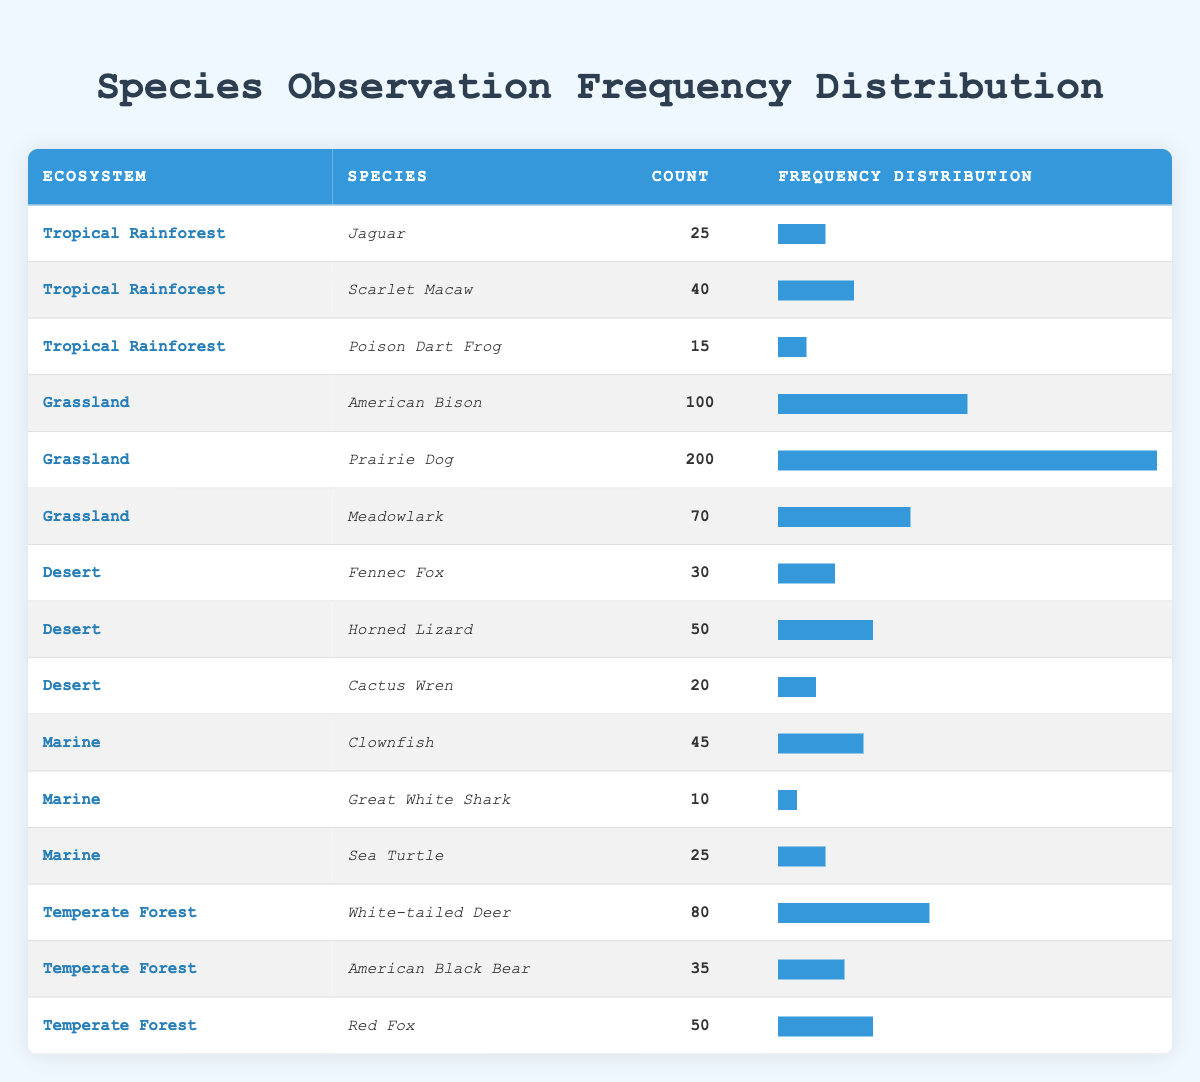What is the highest species observation count in the Grassland ecosystem? By reviewing the Grassland entries, I can see the counts for the species: American Bison (100), Prairie Dog (200), and Meadowlark (70). The highest count is 200 for the Prairie Dog.
Answer: 200 Which species has the lowest observation count in the Tropical Rainforest? In the Tropical Rainforest section, the counts are Jaguar (25), Scarlet Macaw (40), and Poison Dart Frog (15). The Poison Dart Frog has the lowest count at 15.
Answer: 15 Is it true that the Marine ecosystem has more species observed than the Desert ecosystem? The Marine ecosystem lists three species (Clownfish, Great White Shark, Sea Turtle), while the Desert ecosystem lists three as well (Fennec Fox, Horned Lizard, Cactus Wren); therefore, both have the same number of species observed, making the statement false.
Answer: No What is the total observation count for all species in the Temperate Forest ecosystem? The species in the Temperate Forest are White-tailed Deer (80), American Black Bear (35), and Red Fox (50). Adding these counts: 80 + 35 + 50 = 165 gives a total observation count of 165.
Answer: 165 What percentage of the total observation counts does the Prairie Dog represent? The total counts across all species are calculated as follows: 25 (Jaguar) + 40 (Scarlet Macaw) + 15 (Poison Dart Frog) + 100 (American Bison) + 200 (Prairie Dog) + 70 (Meadowlark) + 30 (Fennec Fox) + 50 (Horned Lizard) + 20 (Cactus Wren) + 45 (Clownfish) + 10 (Great White Shark) + 25 (Sea Turtle) + 80 (White-tailed Deer) + 35 (American Black Bear) + 50 (Red Fox) = 680. The count for Prairie Dog is 200. To find the percentage: (200/680) * 100 = 29.41%.
Answer: 29.41% How many ecosystems have a species with an observation count of 50 or more? Looking through each ecosystem's observations, the following counts are 100 (Grassland, American Bison), 200 (Grassland, Prairie Dog), 70 (Grassland, Meadowlark), 50 (Desert, Horned Lizard), 45 (Marine, Clownfish), 80 (Temperate Forest, White-tailed Deer), 50 (Temperate Forest, Red Fox), and the total species with counts of 50 or more sums up to 5 unique ecosystems: Grassland, Desert, Marine, and Temperate Forest.
Answer: 4 What is the average observation count of species in the Desert ecosystem? The species in the Desert ecosystem are Fennec Fox (30), Horned Lizard (50), and Cactus Wren (20). The total count for these species is 30 + 50 + 20 = 100. The average is thus calculated by dividing by the number of species, which is 3: 100 / 3 = 33.33.
Answer: 33.33 